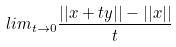Convert formula to latex. <formula><loc_0><loc_0><loc_500><loc_500>l i m _ { t \rightarrow 0 } \frac { | | x + t y | | - | | x | | } { t }</formula> 